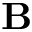Convert formula to latex. <formula><loc_0><loc_0><loc_500><loc_500>B</formula> 